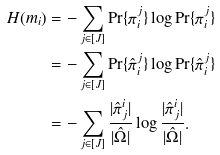<formula> <loc_0><loc_0><loc_500><loc_500>H ( m _ { i } ) & = - \sum _ { j \in [ J ] } \Pr \{ \pi _ { i } ^ { j } \} \log \Pr \{ \pi _ { i } ^ { j } \} \\ & = - \sum _ { j \in [ J ] } \Pr \{ \hat { \pi } _ { i } ^ { j } \} \log \Pr \{ \hat { \pi } _ { i } ^ { j } \} \\ & = - \sum _ { j \in [ J ] } \frac { | \hat { \pi } ^ { i } _ { j } | } { | \hat { \Omega } | } \log \frac { | \hat { \pi } ^ { i } _ { j } | } { | \hat { \Omega } | } .</formula> 